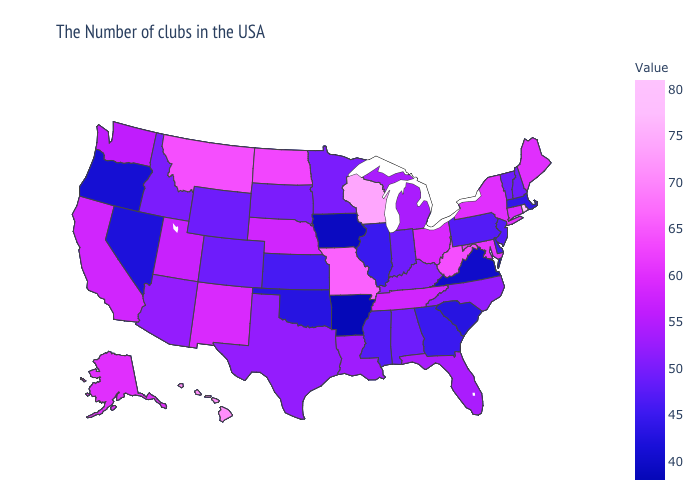Which states have the lowest value in the USA?
Keep it brief. Arkansas. Does Indiana have the highest value in the USA?
Short answer required. No. Which states have the highest value in the USA?
Keep it brief. Rhode Island. Is the legend a continuous bar?
Quick response, please. Yes. Among the states that border North Dakota , which have the lowest value?
Quick response, please. Minnesota, South Dakota. Among the states that border Maine , which have the lowest value?
Quick response, please. New Hampshire. Does the map have missing data?
Keep it brief. No. 